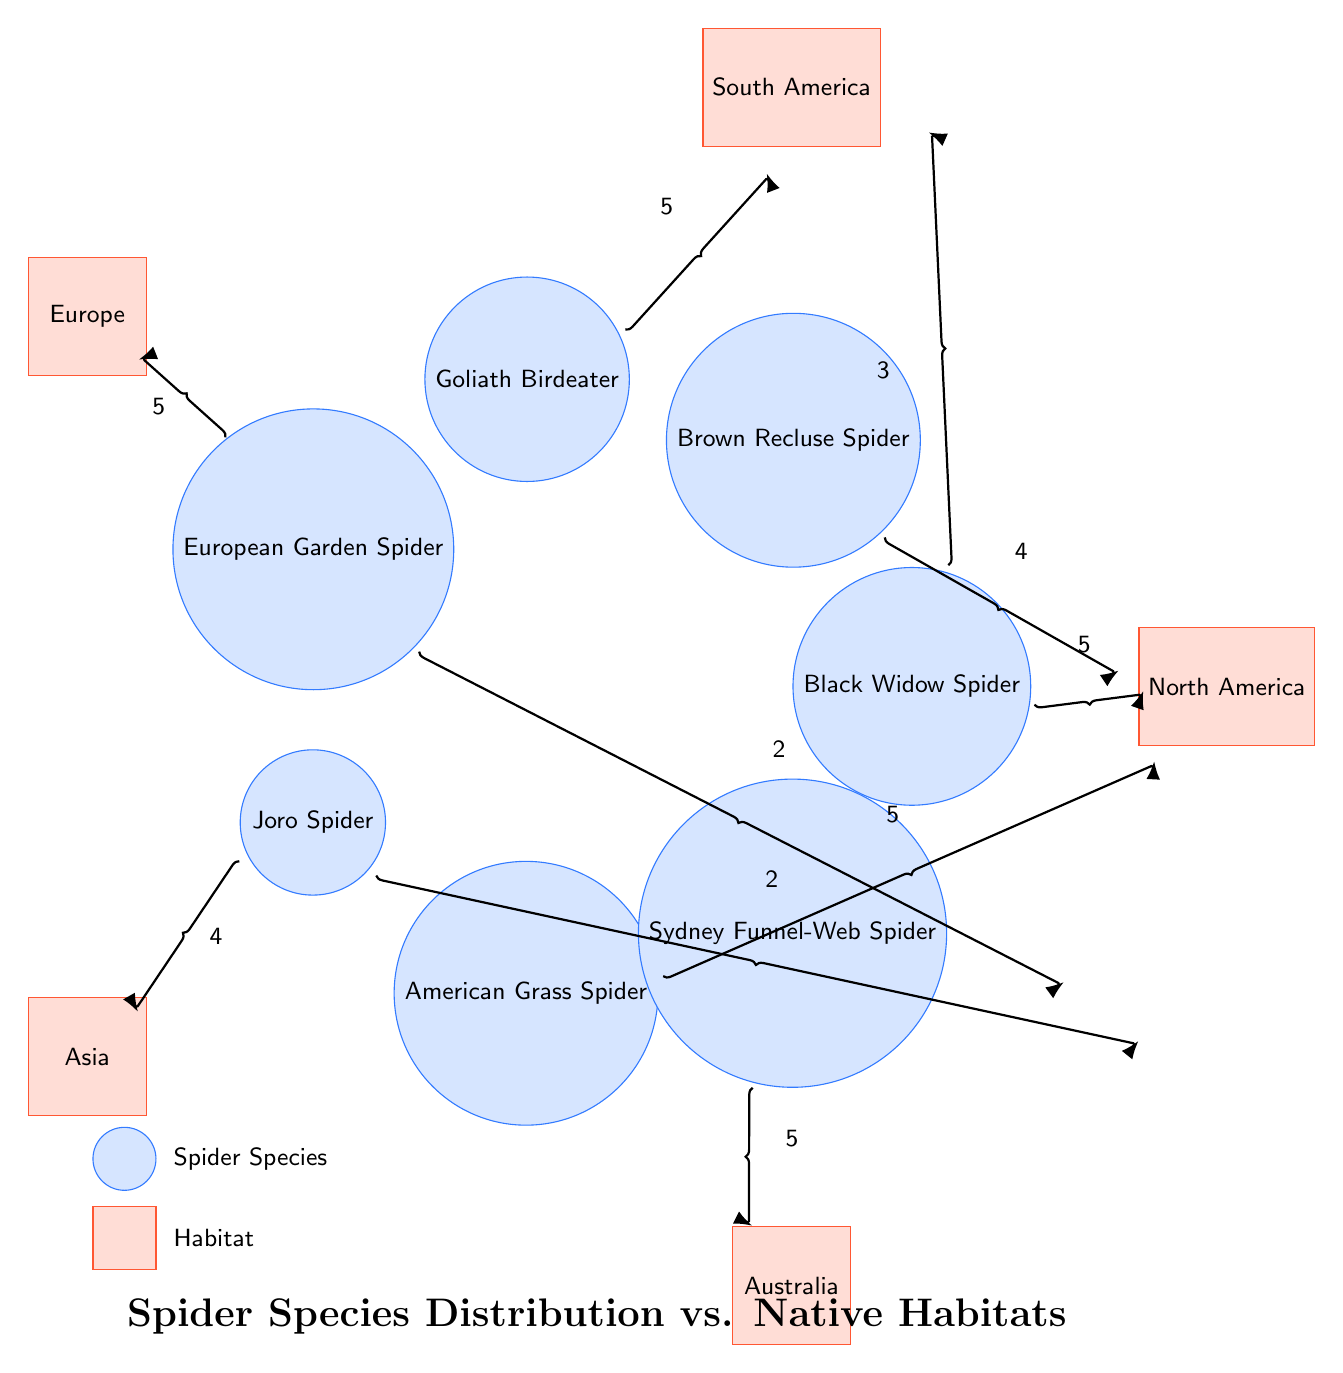What is the habitat of the Black Widow Spider? The Black Widow Spider is connected to North America with a value of 5 and South America with a value of 3, indicating that it has a presence in both regions.
Answer: North America, South America Which spider species is found in Australia? The only spider species linked to Australia is the Sydney Funnel-Web Spider, which connects directly to that habitat with a value of 5.
Answer: Sydney Funnel-Web Spider How many connections does the European Garden Spider have? The European Garden Spider has two connections: one to Europe (5) and another to North America (2), making a total of 2 connections.
Answer: 2 Which spider has the highest distribution value in North America? The American Grass Spider shows a value of 5 in North America, making it the most distributed there compared to other species.
Answer: American Grass Spider What is the value of the connection between the Goliath Birdeater and its habitat? The Goliath Birdeater has a single connection to South America with a value of 5, indicating it is well-distributed there.
Answer: 5 Which spider species is native to Asia? The Joro Spider has a strong connection to Asia with a value of 4, making it the species linked to that habitat.
Answer: Joro Spider What is the total number of distinct habitats represented in the diagram? The diagram includes five distinct habitats: North America, South America, Europe, Asia, and Australia.
Answer: 5 How many spider species are linked to North America? There are four spider species connected to North America: Black Widow Spider, Brown Recluse Spider, European Garden Spider, and American Grass Spider.
Answer: 4 Which spider species has the least presence in North America? The European Garden Spider has the lowest distribution value of 2 in North America, compared to other species.
Answer: European Garden Spider 